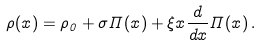<formula> <loc_0><loc_0><loc_500><loc_500>\rho ( x ) = \rho _ { 0 } + \sigma \Pi ( x ) + \xi x \frac { d } { d x } \Pi ( x ) \, .</formula> 